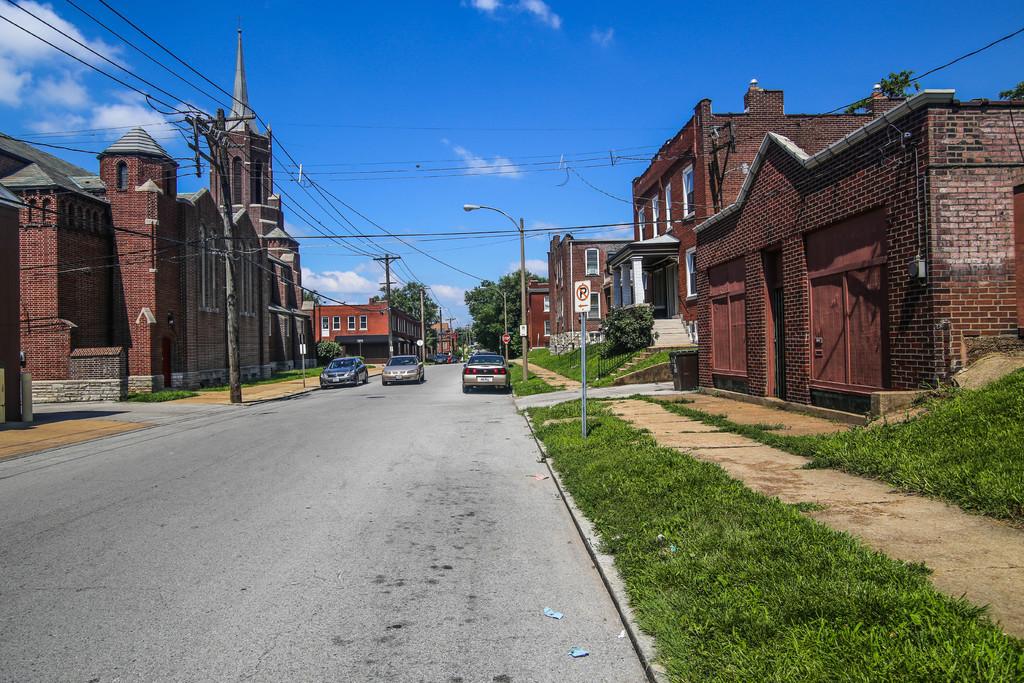What is not allowed on this side of the street?
Your answer should be compact. Parking. 